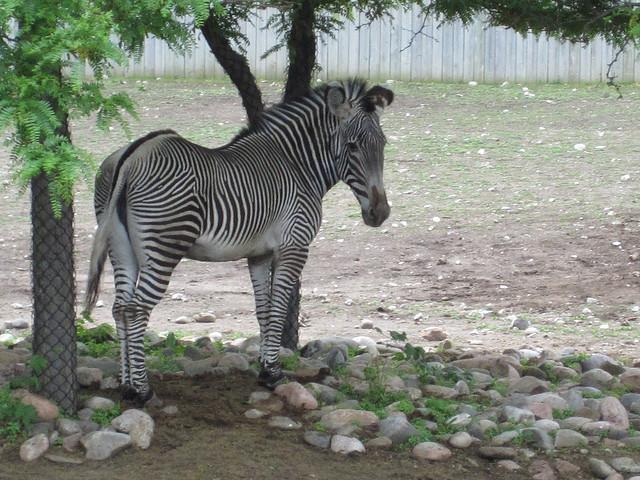Is this animal in an enclosed area?
Be succinct. Yes. What is this animal doing?
Keep it brief. Standing. Is this animal sunbathing?
Answer briefly. No. How many zebras are they?
Short answer required. 1. What color is the  fence?
Short answer required. Gray. 